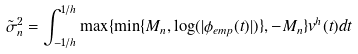<formula> <loc_0><loc_0><loc_500><loc_500>\tilde { \sigma } _ { n } ^ { 2 } = \int _ { - 1 / h } ^ { 1 / h } \max \{ \min \{ M _ { n } , \log ( | \phi _ { e m p } ( t ) | ) \} , - M _ { n } \} v ^ { h } ( t ) d t</formula> 